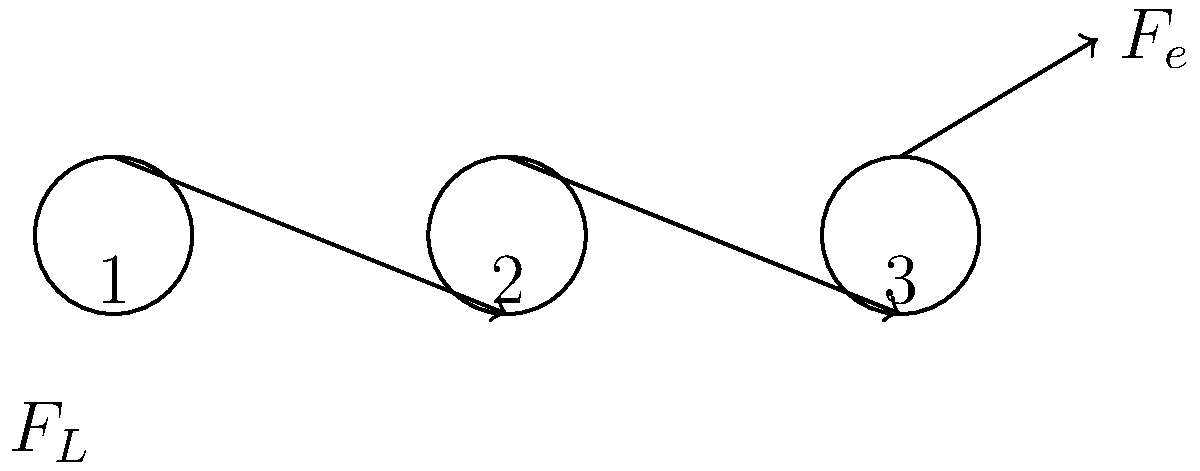During a rock climbing setup, you're using a compound pulley system as shown in the diagram. If the load (climber's weight) is 800 N, what force ($F_e$) is required to lift the climber, assuming the system is frictionless? To solve this problem, we need to calculate the mechanical advantage of the pulley system and then use it to determine the required force.

Step 1: Determine the number of supporting ropes.
In this system, there are 3 supporting ropes (one on each pulley).

Step 2: Calculate the Mechanical Advantage (MA).
The MA of a frictionless pulley system is equal to the number of supporting ropes.
$MA = 3$

Step 3: Use the Mechanical Advantage formula to calculate the required force.
$MA = \frac{F_L}{F_e}$

Where $F_L$ is the load force (climber's weight) and $F_e$ is the effort force (force required to lift).

Rearranging the formula:
$F_e = \frac{F_L}{MA}$

Step 4: Substitute the known values.
$F_e = \frac{800 \text{ N}}{3}$

Step 5: Calculate the result.
$F_e = 266.67 \text{ N}$

Therefore, a force of approximately 266.67 N is required to lift the climber using this pulley system.
Answer: 266.67 N 